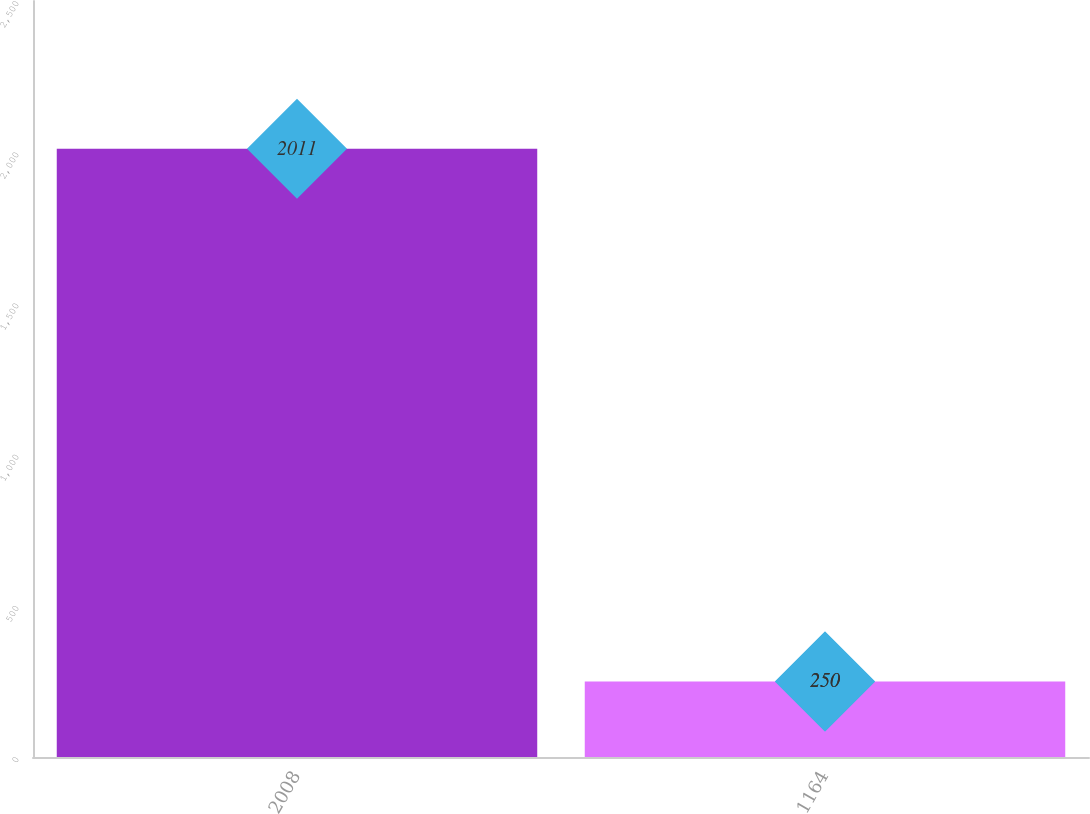Convert chart to OTSL. <chart><loc_0><loc_0><loc_500><loc_500><bar_chart><fcel>2008<fcel>1164<nl><fcel>2011<fcel>250<nl></chart> 